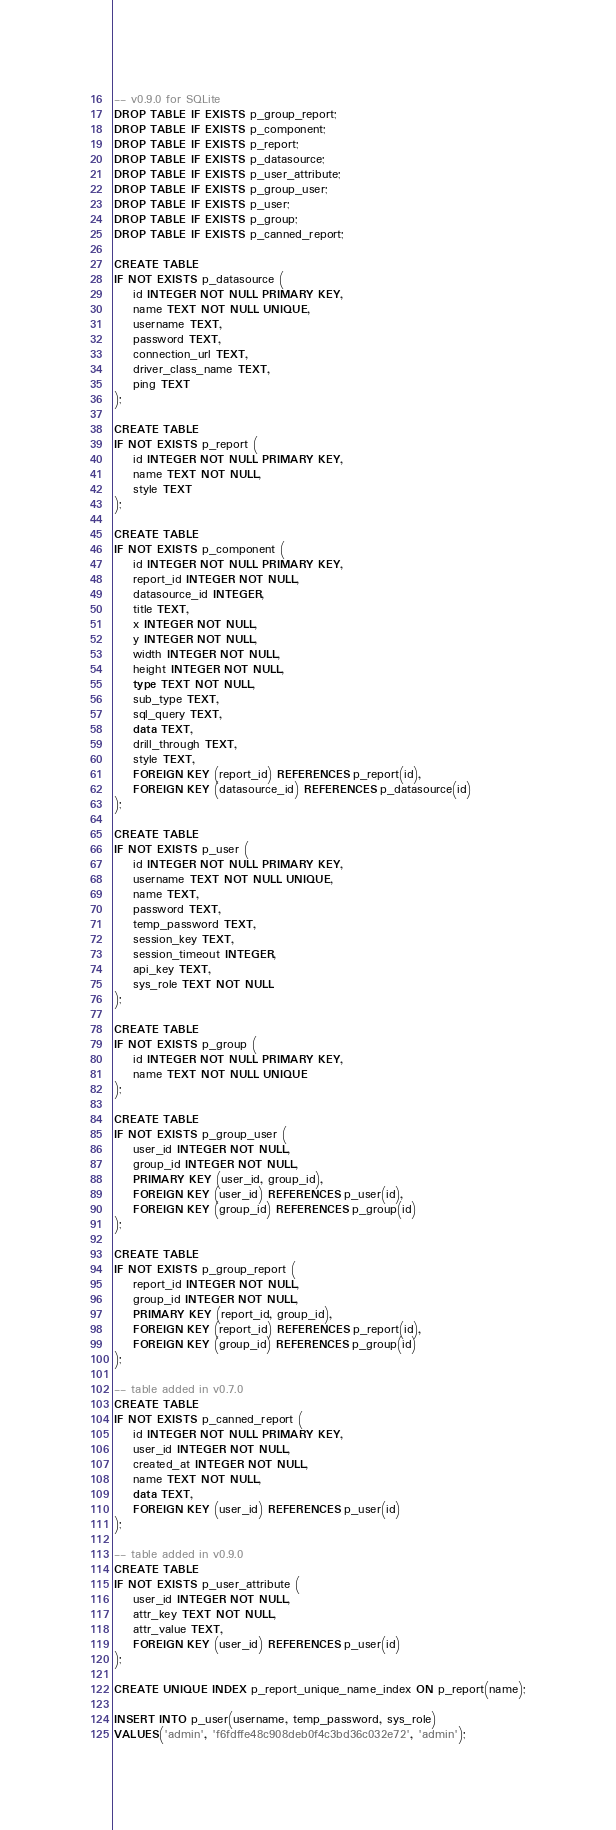Convert code to text. <code><loc_0><loc_0><loc_500><loc_500><_SQL_>-- v0.9.0 for SQLite
DROP TABLE IF EXISTS p_group_report;
DROP TABLE IF EXISTS p_component;
DROP TABLE IF EXISTS p_report;
DROP TABLE IF EXISTS p_datasource;
DROP TABLE IF EXISTS p_user_attribute;
DROP TABLE IF EXISTS p_group_user;
DROP TABLE IF EXISTS p_user;
DROP TABLE IF EXISTS p_group;
DROP TABLE IF EXISTS p_canned_report;

CREATE TABLE
IF NOT EXISTS p_datasource (
    id INTEGER NOT NULL PRIMARY KEY,
    name TEXT NOT NULL UNIQUE,
    username TEXT,
    password TEXT,
    connection_url TEXT,
    driver_class_name TEXT,
    ping TEXT
);

CREATE TABLE
IF NOT EXISTS p_report (
    id INTEGER NOT NULL PRIMARY KEY,
    name TEXT NOT NULL,
    style TEXT
);

CREATE TABLE
IF NOT EXISTS p_component (
    id INTEGER NOT NULL PRIMARY KEY,
    report_id INTEGER NOT NULL,
    datasource_id INTEGER,
    title TEXT,
    x INTEGER NOT NULL,
    y INTEGER NOT NULL,
    width INTEGER NOT NULL,
    height INTEGER NOT NULL,
    type TEXT NOT NULL,
    sub_type TEXT,
    sql_query TEXT,
    data TEXT,
    drill_through TEXT,
    style TEXT,
    FOREIGN KEY (report_id) REFERENCES p_report(id),
    FOREIGN KEY (datasource_id) REFERENCES p_datasource(id)
);

CREATE TABLE 
IF NOT EXISTS p_user (
    id INTEGER NOT NULL PRIMARY KEY,
    username TEXT NOT NULL UNIQUE,
    name TEXT,
    password TEXT,
    temp_password TEXT,
    session_key TEXT,
    session_timeout INTEGER, 
    api_key TEXT,
    sys_role TEXT NOT NULL
);

CREATE TABLE 
IF NOT EXISTS p_group (
    id INTEGER NOT NULL PRIMARY KEY,
    name TEXT NOT NULL UNIQUE
); 

CREATE TABLE 
IF NOT EXISTS p_group_user (
    user_id INTEGER NOT NULL,
    group_id INTEGER NOT NULL,
    PRIMARY KEY (user_id, group_id),
    FOREIGN KEY (user_id) REFERENCES p_user(id),
    FOREIGN KEY (group_id) REFERENCES p_group(id)
); 

CREATE TABLE 
IF NOT EXISTS p_group_report (
    report_id INTEGER NOT NULL,
    group_id INTEGER NOT NULL,
    PRIMARY KEY (report_id, group_id),
    FOREIGN KEY (report_id) REFERENCES p_report(id),
    FOREIGN KEY (group_id) REFERENCES p_group(id)
);

-- table added in v0.7.0
CREATE TABLE
IF NOT EXISTS p_canned_report (
    id INTEGER NOT NULL PRIMARY KEY,
    user_id INTEGER NOT NULL,
    created_at INTEGER NOT NULL,
    name TEXT NOT NULL,
    data TEXT,
    FOREIGN KEY (user_id) REFERENCES p_user(id)
);

-- table added in v0.9.0
CREATE TABLE
IF NOT EXISTS p_user_attribute (
    user_id INTEGER NOT NULL,
    attr_key TEXT NOT NULL,
    attr_value TEXT,
    FOREIGN KEY (user_id) REFERENCES p_user(id)
);

CREATE UNIQUE INDEX p_report_unique_name_index ON p_report(name);

INSERT INTO p_user(username, temp_password, sys_role)
VALUES('admin', 'f6fdffe48c908deb0f4c3bd36c032e72', 'admin');</code> 